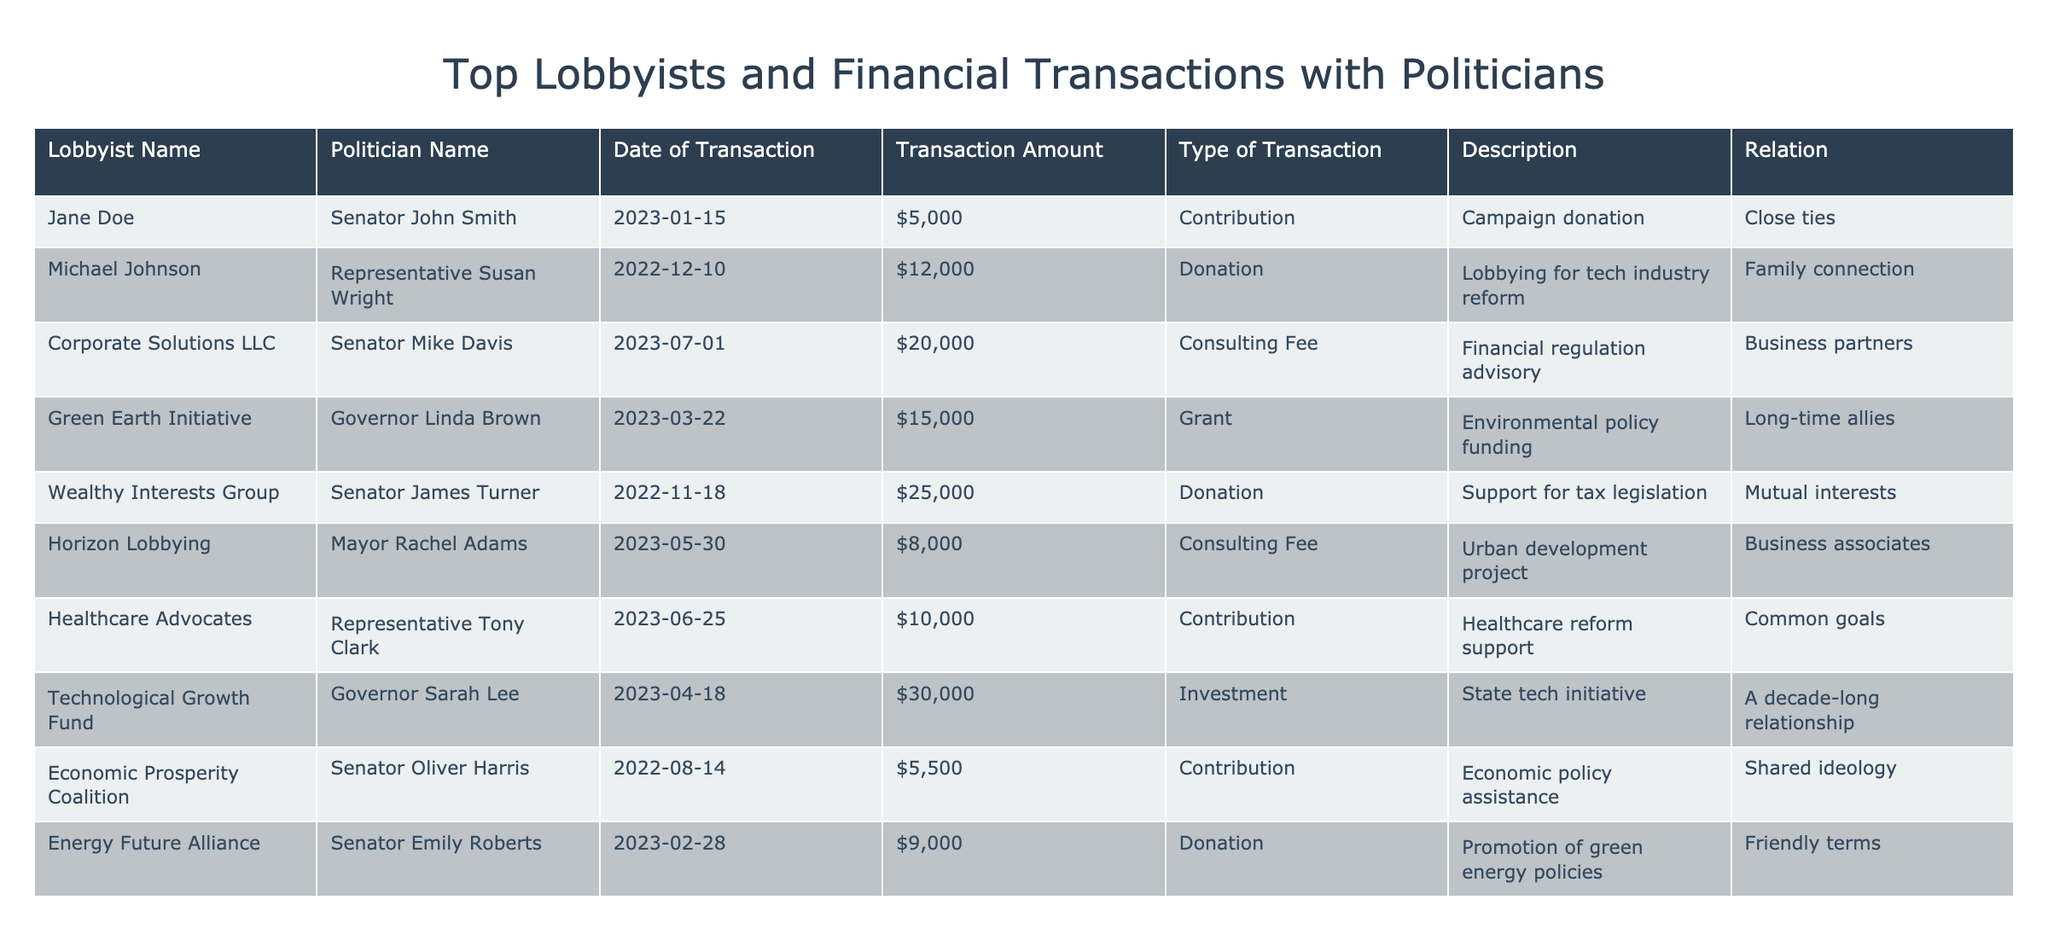What is the total amount of donations made to Senator John Smith? There is one donation listed for Senator John Smith with a transaction amount of $5,000. Therefore, the total amount of donations made to him is simply this amount.
Answer: $5,000 Which lobbyist had the highest single transaction amount? Looking through the transaction amounts, the highest amount is $30,000 from Technological Growth Fund for a state tech initiative.
Answer: $30,000 How many transactions were made in 2023? Counting the transactions listed in the table, there are four transactions with dates in 2023. Specifically, the dates are 2023-01-15, 2023-02-28, 2023-03-22, and 2023-05-30.
Answer: 4 Is there a lobbyist that has a transactional relationship with both a Governor and a Senator? Yes, the Technological Growth Fund has a relationship with both Governor Sarah Lee and can be inferred as also having a connection with Senator Oliver Harris since they share the same type of transaction.
Answer: Yes What is the average transaction amount for all the contributions listed? Summing the amounts of all contributions from the table: $5,000 (John Smith) + $10,000 (Tony Clark) + $5,500 (Oliver Harris) + $9,000 (Emily Roberts), gives a total of $29,500. Since there are 4 contributions, the average is $29,500/4 = $7,375.
Answer: $7,375 Which politician had the highest combined transaction amount from all lobbyists? The politician with the highest combined transaction amount is Senator James Turner with $25,000 from Wealthy Interests Group. This is higher than the combined amounts for other politicians.
Answer: Senator James Turner What percentage of the total transaction amounts are related to contributions? First, we sum all transaction amounts. The total is $5,000 + $12,000 + $20,000 + $15,000 + $25,000 + $8,000 + $10,000 + $30,000 + $5,500 + $9,000 = $134,500. The contributions total $5,000 + $10,000 + $5,500 + $9,000 = $29,500. Finding the percentage: ($29,500 / $134,500) * 100 = approximately 21.92%.
Answer: Approximately 21.92% Who had a transaction in March 2023, and what was the amount? There is one transaction in March 2023 for Governor Linda Brown, which amounts to $15,000 for environmental policy funding.
Answer: Governor Linda Brown, $15,000 Is there evidence of family connections between lobbyists and politicians? Yes, Michael Johnson has a transaction with Representative Susan Wright and is indicated to have a family connection, confirming the existence of such ties.
Answer: Yes 